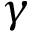Convert formula to latex. <formula><loc_0><loc_0><loc_500><loc_500>\gamma</formula> 